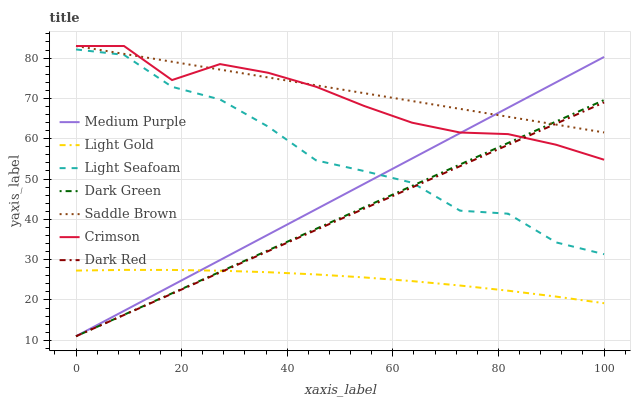Does Light Gold have the minimum area under the curve?
Answer yes or no. Yes. Does Saddle Brown have the maximum area under the curve?
Answer yes or no. Yes. Does Medium Purple have the minimum area under the curve?
Answer yes or no. No. Does Medium Purple have the maximum area under the curve?
Answer yes or no. No. Is Dark Red the smoothest?
Answer yes or no. Yes. Is Light Seafoam the roughest?
Answer yes or no. Yes. Is Medium Purple the smoothest?
Answer yes or no. No. Is Medium Purple the roughest?
Answer yes or no. No. Does Dark Red have the lowest value?
Answer yes or no. Yes. Does Crimson have the lowest value?
Answer yes or no. No. Does Saddle Brown have the highest value?
Answer yes or no. Yes. Does Medium Purple have the highest value?
Answer yes or no. No. Is Light Gold less than Light Seafoam?
Answer yes or no. Yes. Is Light Seafoam greater than Light Gold?
Answer yes or no. Yes. Does Dark Green intersect Dark Red?
Answer yes or no. Yes. Is Dark Green less than Dark Red?
Answer yes or no. No. Is Dark Green greater than Dark Red?
Answer yes or no. No. Does Light Gold intersect Light Seafoam?
Answer yes or no. No. 